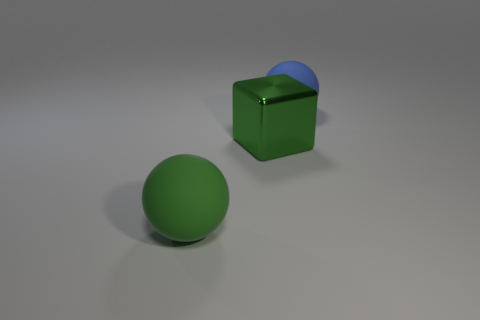Add 2 blue rubber balls. How many objects exist? 5 Subtract all cubes. How many objects are left? 2 Subtract all green rubber balls. Subtract all green spheres. How many objects are left? 1 Add 1 big balls. How many big balls are left? 3 Add 1 rubber balls. How many rubber balls exist? 3 Subtract 1 green cubes. How many objects are left? 2 